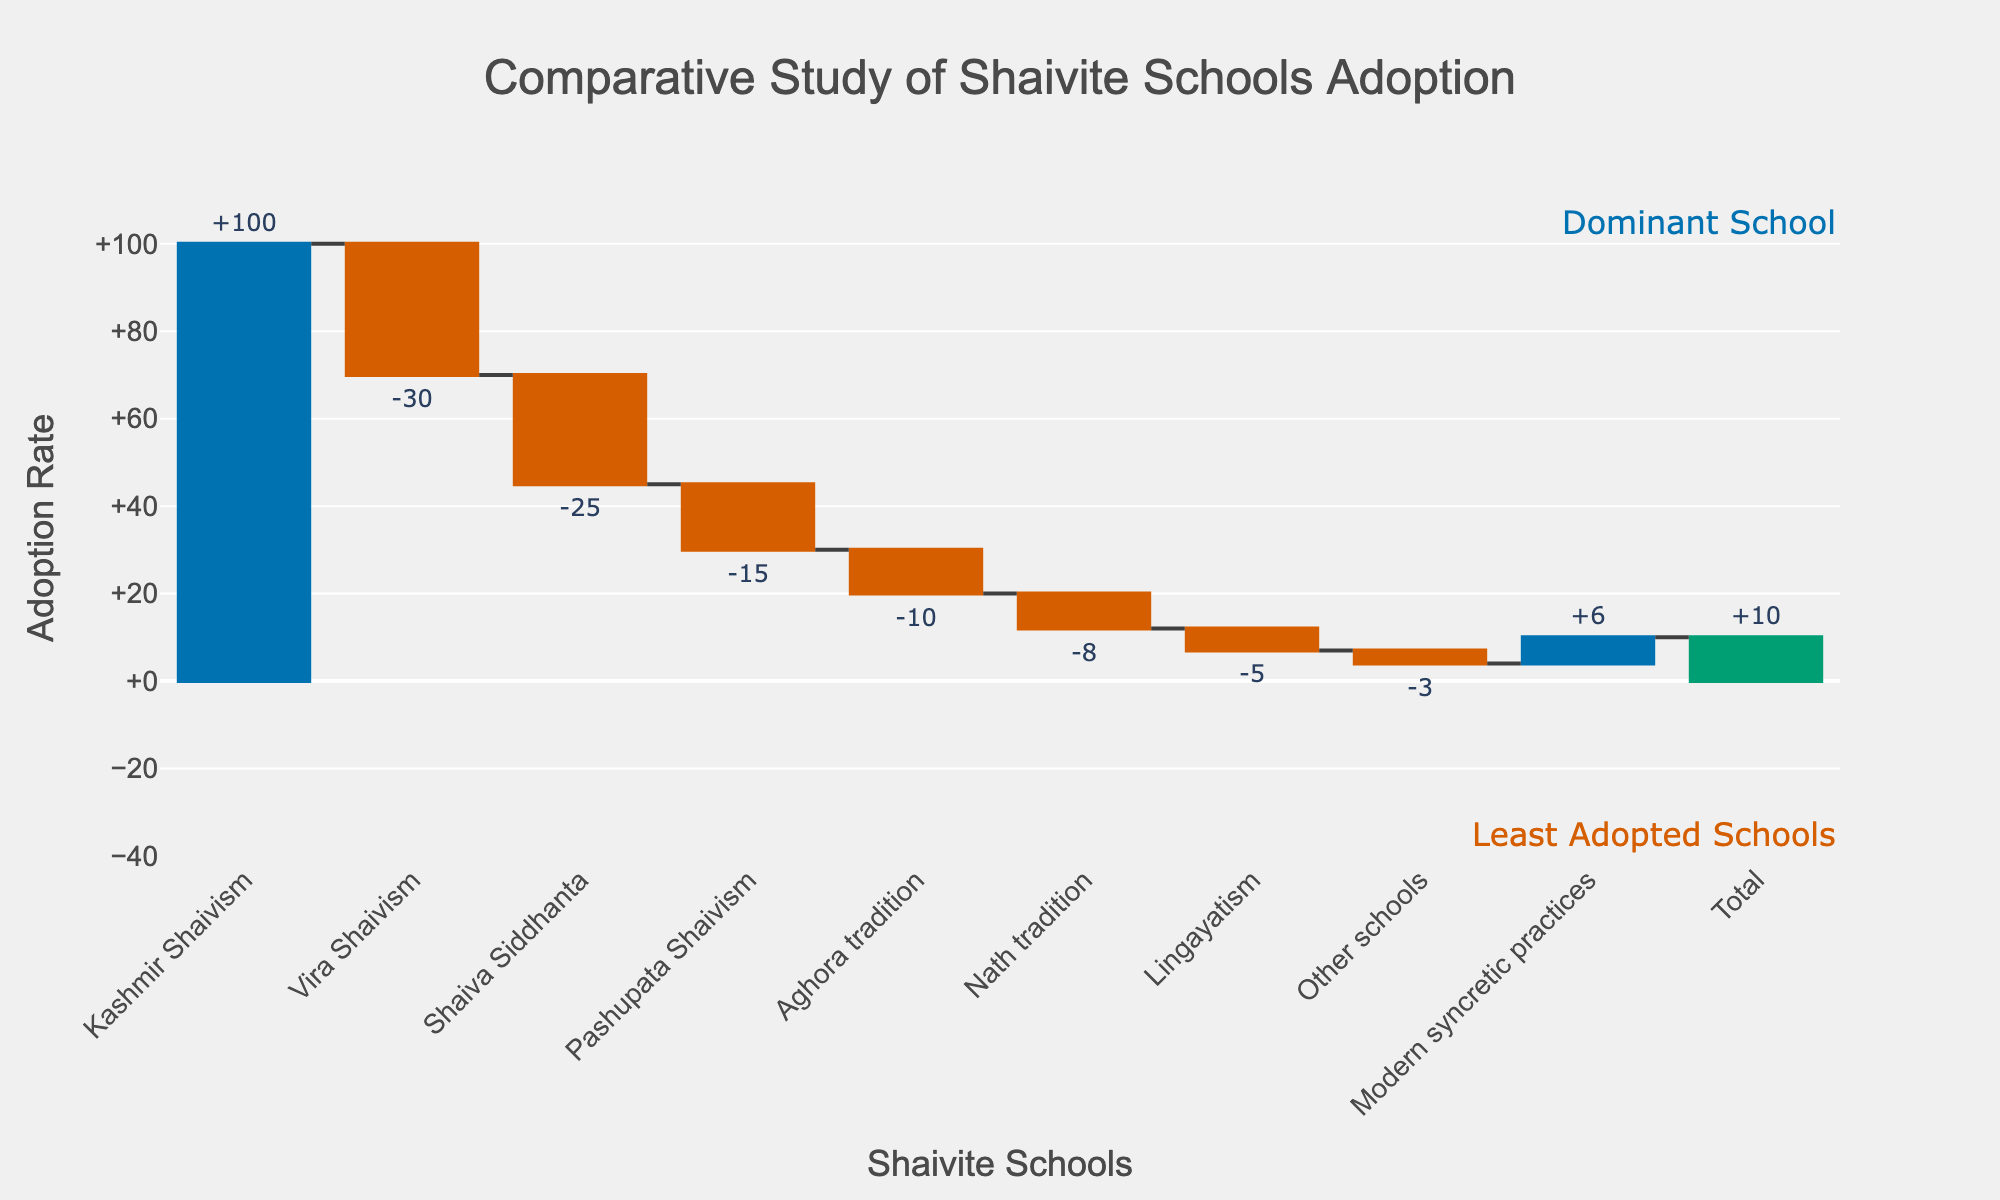what is the main title of the chart? The main title is located at the top of the chart. It provides an overview of the data being represented. In this case, the main title is "Comparative Study of Shaivite Schools Adoption".
Answer: Comparative Study of Shaivite Schools Adoption Which Shaivite philosophical school has the highest adoption rate among modern practitioners? The highest adoption rate is indicated by the largest blue bar in the chart, to the right of the origin. In this case, it is "Kashmir Shaivism" with an adoption value of 100.
Answer: Kashmir Shaivism What is the total combined effect of the negative adoption rates? To find the total effect of the negative adoption rates, sum all the negative values: -30 (Vira Shaivism) + -25 (Shaiva Siddhanta) + -15 (Pashupata Shaivism) + -10 (Aghora tradition) + -8 (Nath tradition) + -5 (Lingayatism) + -3 (Other schools) = -96.
Answer: -96 Which two schools have the smallest absolute adoption values, and how do they compare? The chart shows various adoption values; the categories with the smallest absolute values are "Other schools" at -3 and "Modern syncretic practices" at +6. Comparing them, "Other schools" has a negative adoption value while "Modern syncretic practices" has a positive one.
Answer: Other schools and Modern syncretic practices; -3 and +6 By how much does the adoption rate of Kashmir Shaivism surpass that of Shaiva Siddhanta? The adoption rate of Kashmir Shaivism is 100, and the adoption rate of Shaiva Siddhanta is -25. The difference is found by subtracting: 100 - -25 = 125.
Answer: 125 How does the adoption rate of Modern syncretic practices influence the total adoption rate? The rate for Modern syncretic practices is +6, which contributes positively to the total adoption rate, pushing the final total to 10 as indicated at the end of the waterfall chart.
Answer: +6 What is the final total adoption rate and how is it indicated in the chart? The final total adoption rate is shown as the last bar in the chart, marked in green, representing the cumulative result of all previous values. The total adoption rate is 10.
Answer: 10 Which Shaivite school showed the smallest decline in adoption rate? Among the schools with a negative adoption rate, "Other schools" shows the smallest decline with a value of -3.
Answer: Other schools 